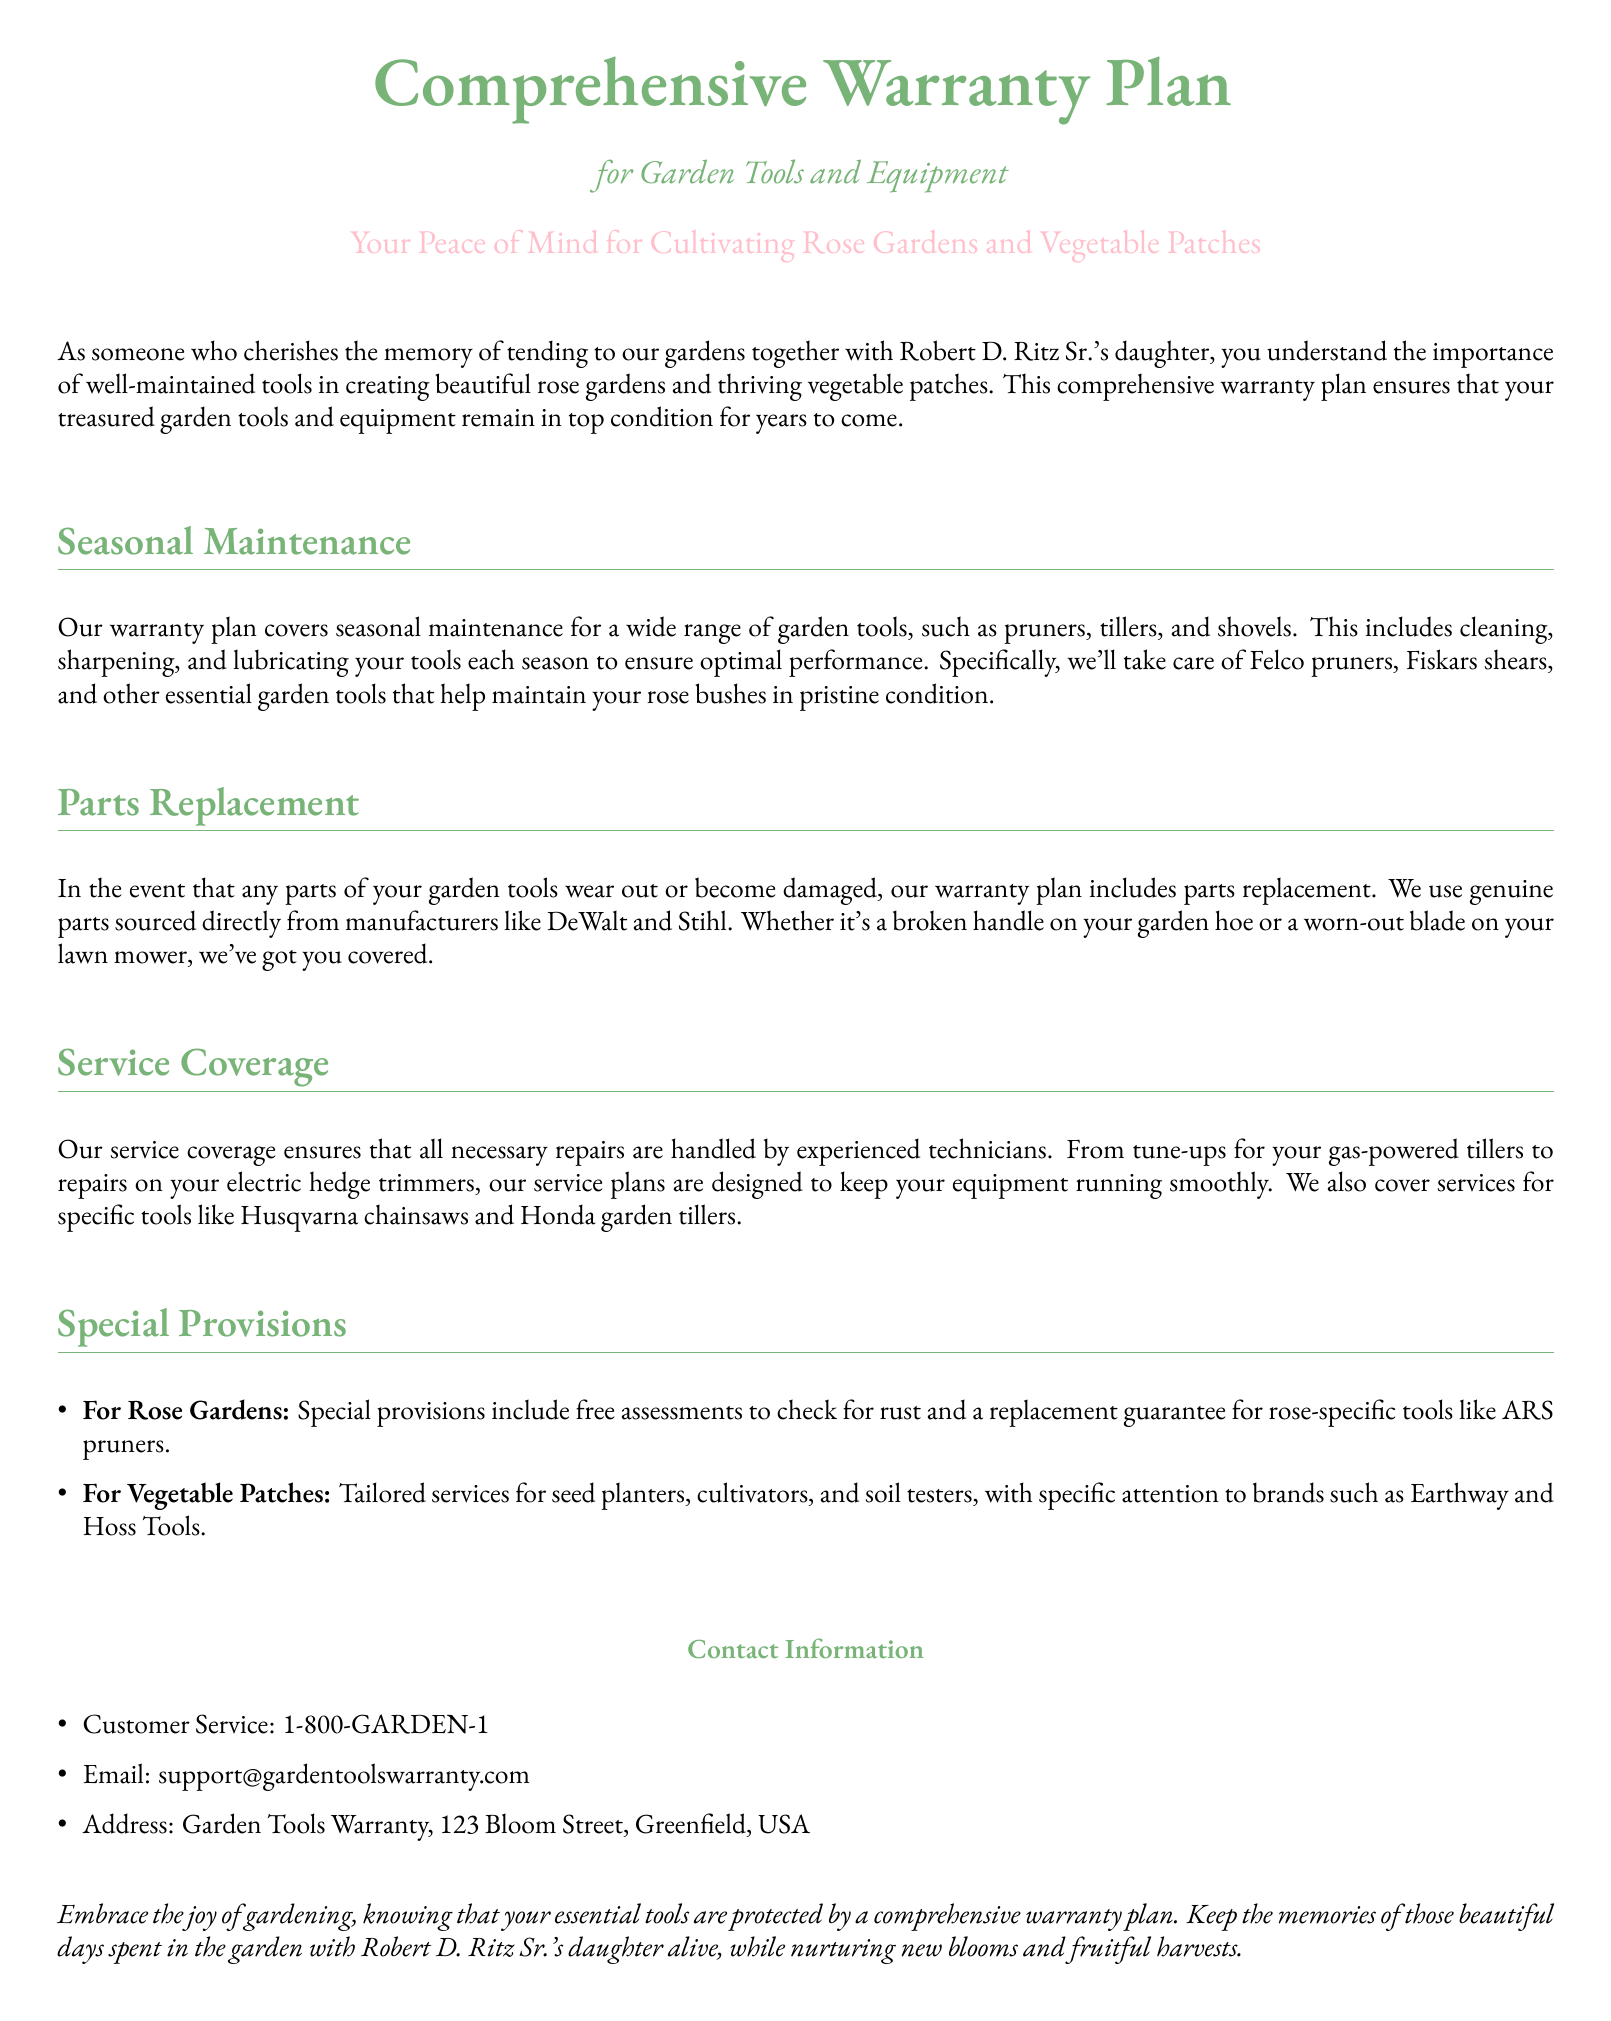What does the warranty plan cover for garden tools? The warranty plan covers seasonal maintenance, parts replacement, and service for garden tools and equipment.
Answer: Seasonal maintenance, parts replacement, and service What seasonal task is included in the maintenance? The maintenance includes cleaning, sharpening, and lubricating your tools each season.
Answer: Cleaning, sharpening, and lubricating Which brand's tools are specifically mentioned for parts replacement? The document specifies brands like DeWalt and Stihl for parts replacement.
Answer: DeWalt and Stihl What type of tools are specifically covered for rose gardens? The warranty includes special provisions for rose-specific tools like ARS pruners.
Answer: ARS pruners How can customers contact the support team? The document provides customer service phone number, email, and address for contacting support.
Answer: 1-800-GARDEN-1, support@gardentoolswarranty.com, Garden Tools Warranty, 123 Bloom Street What type of service is provided for vegetable patches? Tailored services for seed planters, cultivators, and soil testers are provided for vegetable patches.
Answer: Seed planters, cultivators, and soil testers What is the purpose of the warranty plan? The purpose of the warranty plan is to ensure that garden tools and equipment remain in top condition.
Answer: Ensure garden tools and equipment remain in top condition What does the warranty cover for Husqvarna chainsaws? The warranty includes repairs and tune-ups for Husqvarna chainsaws.
Answer: Repairs and tune-ups Which seasonal maintenance is specified for Felco pruners? The maintenance specified includes cleaning, sharpening, and lubricating Felco pruners.
Answer: Cleaning, sharpening, and lubricating 